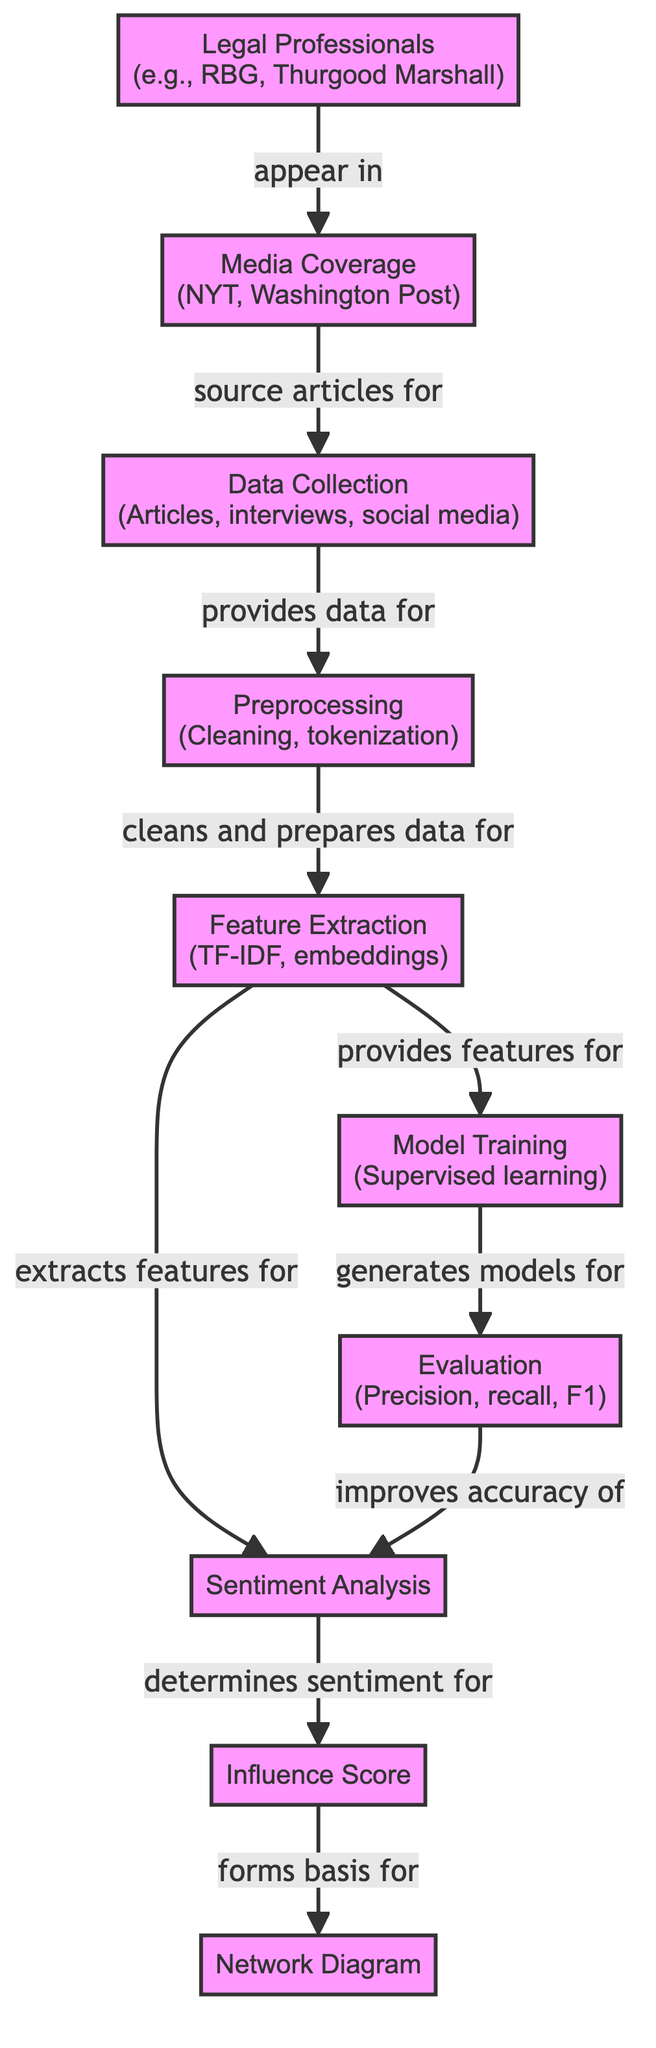What data sources are involved in the data collection? The diagram indicates that data collection comes from articles, interviews, and social media. These are explicitly mentioned in the node labeled "Data Collection."
Answer: Articles, interviews, social media Which legal professionals are highlighted in this diagram? The diagram features "Legal Professionals" with examples such as RBG (Ruth Bader Ginsburg) and Thurgood Marshall. Therefore, they represent the notable figures in the legal sector discussed in the diagram.
Answer: RBG, Thurgood Marshall What is the purpose of the influence score in the diagram? According to the flow in the diagram, the influence score is derived from sentiment analysis and forms the basis for creating the network diagram. It indicates its significance in connecting sentiment analysis results to the network representation.
Answer: Forms basis for network diagram How many primary processes are shown in this diagram? By counting the individual nodes representing distinct steps or components such as "Data Collection," "Preprocessing," and others, the total number of processes can be determined. In this case, there are nine identified processes that shape the overall functioning of the diagram.
Answer: Nine What type of model training is referenced in the diagram? The diagram specifies that the model training uses supervised learning, which is highlighted in the "Model Training" node. This indicates the method of training employed in the process depicted.
Answer: Supervised learning How does preprocessing relate to feature extraction? The relationship shown in the diagram indicates that preprocessing cleans and prepares the data for feature extraction. It suggests that preprocessing is a necessary step before feature extraction can occur.
Answer: Cleans and prepares data for feature extraction Which step directly influences the accuracy of sentiment analysis? The diagram shows that the evaluation step, which includes precision, recall, and F1 measures, directly impacts the accuracy of sentiment analysis, indicating a cycle of improvement.
Answer: Improves accuracy of sentiment analysis What type of data does the feature extraction process derive? The feature extraction node represents that it extracts features using methods like TF-IDF and embeddings, demonstrating the techniques used to process the data into analyzable features.
Answer: TF-IDF, embeddings Which node indicates the application of the extracted features? The flowchart describes that extracted features from the feature extraction node are utilized for model training, showcasing how features are applied to train models.
Answer: Model Training 